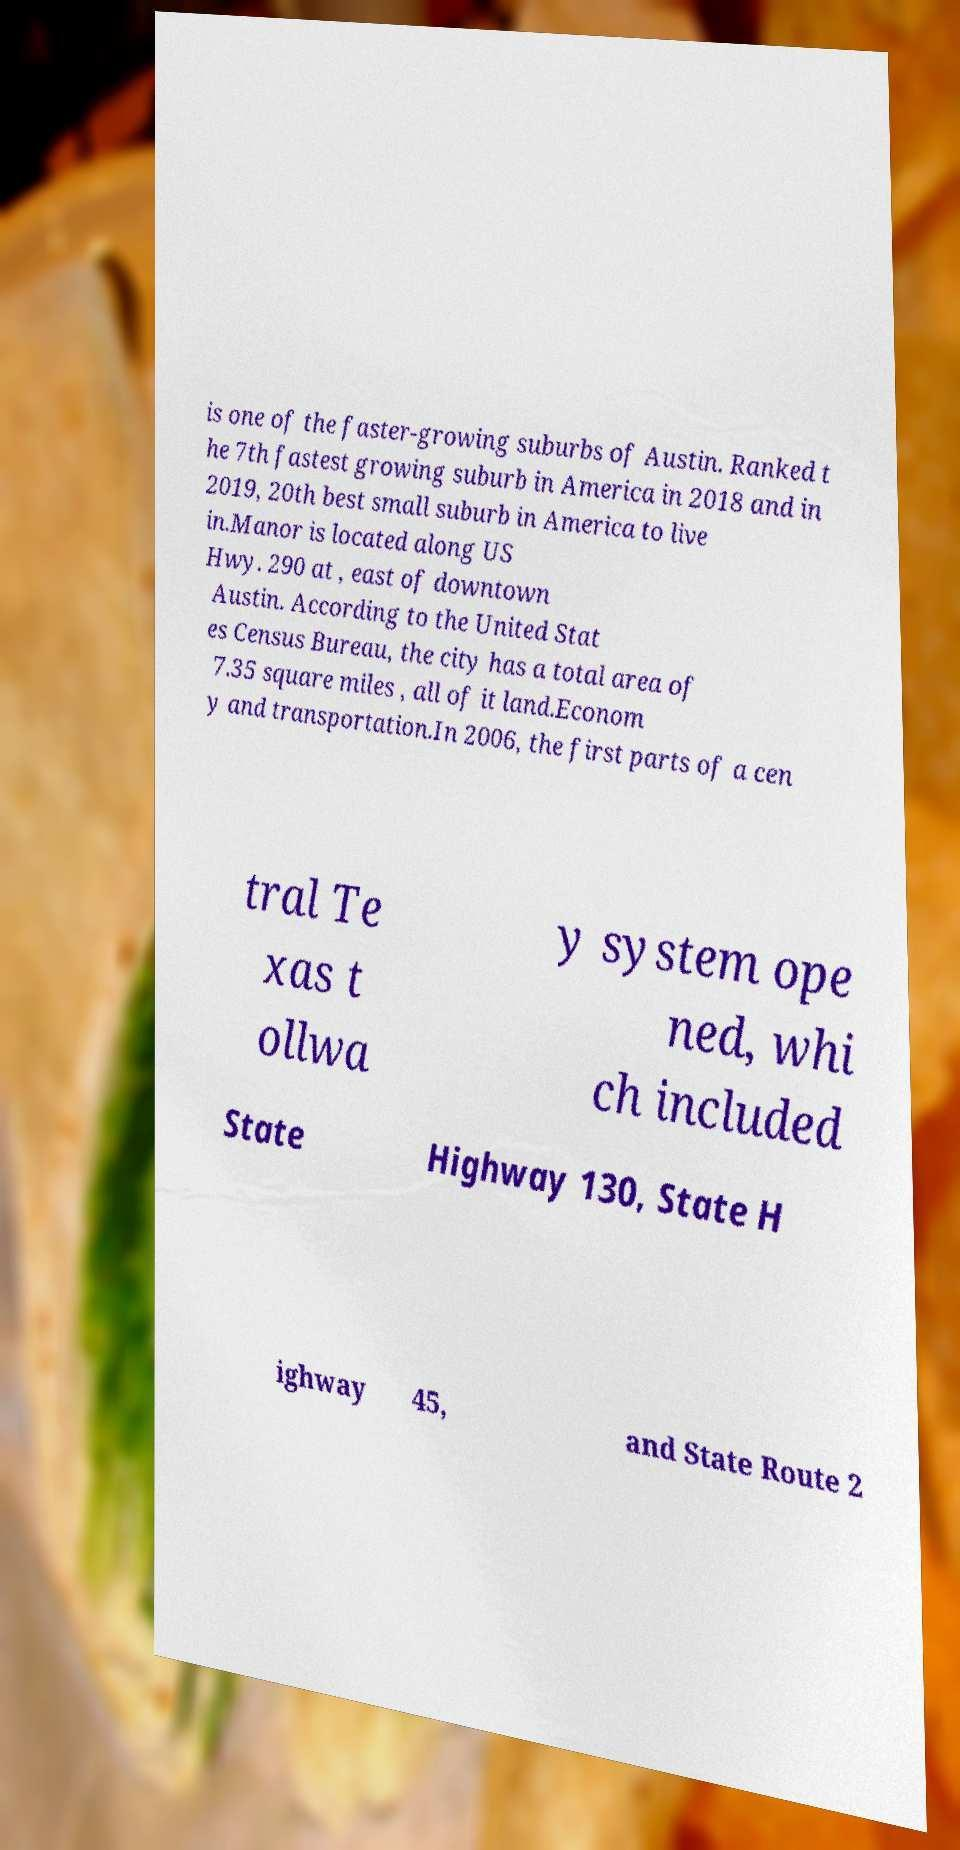Please identify and transcribe the text found in this image. is one of the faster-growing suburbs of Austin. Ranked t he 7th fastest growing suburb in America in 2018 and in 2019, 20th best small suburb in America to live in.Manor is located along US Hwy. 290 at , east of downtown Austin. According to the United Stat es Census Bureau, the city has a total area of 7.35 square miles , all of it land.Econom y and transportation.In 2006, the first parts of a cen tral Te xas t ollwa y system ope ned, whi ch included State Highway 130, State H ighway 45, and State Route 2 